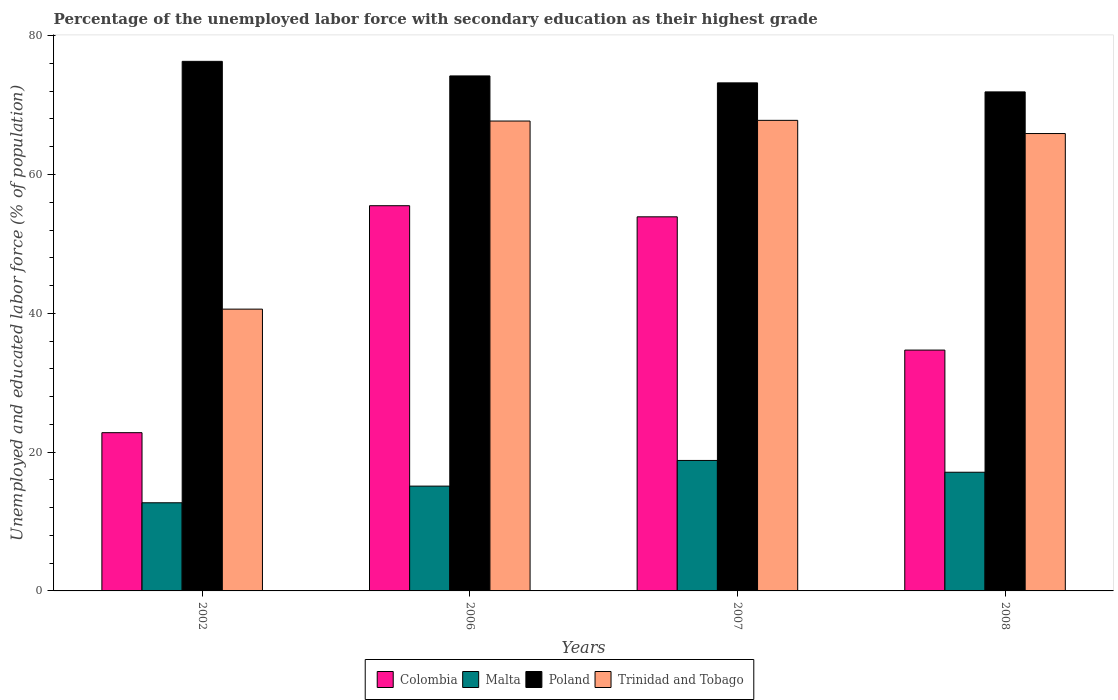How many different coloured bars are there?
Provide a short and direct response. 4. How many groups of bars are there?
Offer a terse response. 4. What is the percentage of the unemployed labor force with secondary education in Malta in 2008?
Your answer should be compact. 17.1. Across all years, what is the maximum percentage of the unemployed labor force with secondary education in Colombia?
Offer a very short reply. 55.5. Across all years, what is the minimum percentage of the unemployed labor force with secondary education in Malta?
Your answer should be very brief. 12.7. In which year was the percentage of the unemployed labor force with secondary education in Malta maximum?
Give a very brief answer. 2007. In which year was the percentage of the unemployed labor force with secondary education in Malta minimum?
Make the answer very short. 2002. What is the total percentage of the unemployed labor force with secondary education in Colombia in the graph?
Provide a short and direct response. 166.9. What is the difference between the percentage of the unemployed labor force with secondary education in Colombia in 2006 and that in 2008?
Your answer should be very brief. 20.8. What is the difference between the percentage of the unemployed labor force with secondary education in Trinidad and Tobago in 2008 and the percentage of the unemployed labor force with secondary education in Poland in 2006?
Your response must be concise. -8.3. What is the average percentage of the unemployed labor force with secondary education in Colombia per year?
Provide a short and direct response. 41.73. In the year 2002, what is the difference between the percentage of the unemployed labor force with secondary education in Malta and percentage of the unemployed labor force with secondary education in Poland?
Offer a terse response. -63.6. In how many years, is the percentage of the unemployed labor force with secondary education in Colombia greater than 8 %?
Provide a short and direct response. 4. What is the ratio of the percentage of the unemployed labor force with secondary education in Colombia in 2006 to that in 2008?
Offer a very short reply. 1.6. Is the percentage of the unemployed labor force with secondary education in Colombia in 2007 less than that in 2008?
Offer a very short reply. No. What is the difference between the highest and the second highest percentage of the unemployed labor force with secondary education in Malta?
Give a very brief answer. 1.7. What is the difference between the highest and the lowest percentage of the unemployed labor force with secondary education in Trinidad and Tobago?
Your response must be concise. 27.2. Is it the case that in every year, the sum of the percentage of the unemployed labor force with secondary education in Poland and percentage of the unemployed labor force with secondary education in Colombia is greater than the sum of percentage of the unemployed labor force with secondary education in Malta and percentage of the unemployed labor force with secondary education in Trinidad and Tobago?
Your answer should be very brief. No. What does the 2nd bar from the right in 2006 represents?
Your response must be concise. Poland. How many years are there in the graph?
Provide a succinct answer. 4. What is the difference between two consecutive major ticks on the Y-axis?
Ensure brevity in your answer.  20. Does the graph contain grids?
Provide a short and direct response. No. Where does the legend appear in the graph?
Your response must be concise. Bottom center. How are the legend labels stacked?
Provide a succinct answer. Horizontal. What is the title of the graph?
Your answer should be very brief. Percentage of the unemployed labor force with secondary education as their highest grade. Does "Cambodia" appear as one of the legend labels in the graph?
Your answer should be compact. No. What is the label or title of the Y-axis?
Keep it short and to the point. Unemployed and educated labor force (% of population). What is the Unemployed and educated labor force (% of population) in Colombia in 2002?
Offer a very short reply. 22.8. What is the Unemployed and educated labor force (% of population) of Malta in 2002?
Keep it short and to the point. 12.7. What is the Unemployed and educated labor force (% of population) in Poland in 2002?
Your response must be concise. 76.3. What is the Unemployed and educated labor force (% of population) of Trinidad and Tobago in 2002?
Your answer should be compact. 40.6. What is the Unemployed and educated labor force (% of population) in Colombia in 2006?
Provide a short and direct response. 55.5. What is the Unemployed and educated labor force (% of population) of Malta in 2006?
Your response must be concise. 15.1. What is the Unemployed and educated labor force (% of population) of Poland in 2006?
Offer a very short reply. 74.2. What is the Unemployed and educated labor force (% of population) of Trinidad and Tobago in 2006?
Keep it short and to the point. 67.7. What is the Unemployed and educated labor force (% of population) in Colombia in 2007?
Offer a very short reply. 53.9. What is the Unemployed and educated labor force (% of population) of Malta in 2007?
Offer a very short reply. 18.8. What is the Unemployed and educated labor force (% of population) of Poland in 2007?
Give a very brief answer. 73.2. What is the Unemployed and educated labor force (% of population) in Trinidad and Tobago in 2007?
Give a very brief answer. 67.8. What is the Unemployed and educated labor force (% of population) in Colombia in 2008?
Offer a very short reply. 34.7. What is the Unemployed and educated labor force (% of population) in Malta in 2008?
Offer a terse response. 17.1. What is the Unemployed and educated labor force (% of population) in Poland in 2008?
Offer a very short reply. 71.9. What is the Unemployed and educated labor force (% of population) of Trinidad and Tobago in 2008?
Your answer should be compact. 65.9. Across all years, what is the maximum Unemployed and educated labor force (% of population) of Colombia?
Offer a terse response. 55.5. Across all years, what is the maximum Unemployed and educated labor force (% of population) in Malta?
Your response must be concise. 18.8. Across all years, what is the maximum Unemployed and educated labor force (% of population) of Poland?
Ensure brevity in your answer.  76.3. Across all years, what is the maximum Unemployed and educated labor force (% of population) in Trinidad and Tobago?
Keep it short and to the point. 67.8. Across all years, what is the minimum Unemployed and educated labor force (% of population) of Colombia?
Your response must be concise. 22.8. Across all years, what is the minimum Unemployed and educated labor force (% of population) of Malta?
Make the answer very short. 12.7. Across all years, what is the minimum Unemployed and educated labor force (% of population) in Poland?
Your answer should be very brief. 71.9. Across all years, what is the minimum Unemployed and educated labor force (% of population) of Trinidad and Tobago?
Offer a terse response. 40.6. What is the total Unemployed and educated labor force (% of population) in Colombia in the graph?
Offer a very short reply. 166.9. What is the total Unemployed and educated labor force (% of population) in Malta in the graph?
Give a very brief answer. 63.7. What is the total Unemployed and educated labor force (% of population) in Poland in the graph?
Offer a very short reply. 295.6. What is the total Unemployed and educated labor force (% of population) of Trinidad and Tobago in the graph?
Your response must be concise. 242. What is the difference between the Unemployed and educated labor force (% of population) of Colombia in 2002 and that in 2006?
Provide a succinct answer. -32.7. What is the difference between the Unemployed and educated labor force (% of population) of Poland in 2002 and that in 2006?
Make the answer very short. 2.1. What is the difference between the Unemployed and educated labor force (% of population) in Trinidad and Tobago in 2002 and that in 2006?
Provide a short and direct response. -27.1. What is the difference between the Unemployed and educated labor force (% of population) in Colombia in 2002 and that in 2007?
Provide a short and direct response. -31.1. What is the difference between the Unemployed and educated labor force (% of population) in Malta in 2002 and that in 2007?
Make the answer very short. -6.1. What is the difference between the Unemployed and educated labor force (% of population) in Trinidad and Tobago in 2002 and that in 2007?
Your answer should be compact. -27.2. What is the difference between the Unemployed and educated labor force (% of population) of Colombia in 2002 and that in 2008?
Make the answer very short. -11.9. What is the difference between the Unemployed and educated labor force (% of population) of Malta in 2002 and that in 2008?
Make the answer very short. -4.4. What is the difference between the Unemployed and educated labor force (% of population) of Poland in 2002 and that in 2008?
Offer a very short reply. 4.4. What is the difference between the Unemployed and educated labor force (% of population) of Trinidad and Tobago in 2002 and that in 2008?
Keep it short and to the point. -25.3. What is the difference between the Unemployed and educated labor force (% of population) of Malta in 2006 and that in 2007?
Give a very brief answer. -3.7. What is the difference between the Unemployed and educated labor force (% of population) in Poland in 2006 and that in 2007?
Give a very brief answer. 1. What is the difference between the Unemployed and educated labor force (% of population) in Trinidad and Tobago in 2006 and that in 2007?
Offer a terse response. -0.1. What is the difference between the Unemployed and educated labor force (% of population) in Colombia in 2006 and that in 2008?
Ensure brevity in your answer.  20.8. What is the difference between the Unemployed and educated labor force (% of population) in Malta in 2006 and that in 2008?
Keep it short and to the point. -2. What is the difference between the Unemployed and educated labor force (% of population) of Poland in 2006 and that in 2008?
Offer a very short reply. 2.3. What is the difference between the Unemployed and educated labor force (% of population) in Colombia in 2007 and that in 2008?
Give a very brief answer. 19.2. What is the difference between the Unemployed and educated labor force (% of population) of Poland in 2007 and that in 2008?
Your answer should be very brief. 1.3. What is the difference between the Unemployed and educated labor force (% of population) in Trinidad and Tobago in 2007 and that in 2008?
Your response must be concise. 1.9. What is the difference between the Unemployed and educated labor force (% of population) in Colombia in 2002 and the Unemployed and educated labor force (% of population) in Malta in 2006?
Ensure brevity in your answer.  7.7. What is the difference between the Unemployed and educated labor force (% of population) of Colombia in 2002 and the Unemployed and educated labor force (% of population) of Poland in 2006?
Ensure brevity in your answer.  -51.4. What is the difference between the Unemployed and educated labor force (% of population) in Colombia in 2002 and the Unemployed and educated labor force (% of population) in Trinidad and Tobago in 2006?
Offer a very short reply. -44.9. What is the difference between the Unemployed and educated labor force (% of population) in Malta in 2002 and the Unemployed and educated labor force (% of population) in Poland in 2006?
Your answer should be very brief. -61.5. What is the difference between the Unemployed and educated labor force (% of population) of Malta in 2002 and the Unemployed and educated labor force (% of population) of Trinidad and Tobago in 2006?
Keep it short and to the point. -55. What is the difference between the Unemployed and educated labor force (% of population) of Poland in 2002 and the Unemployed and educated labor force (% of population) of Trinidad and Tobago in 2006?
Provide a short and direct response. 8.6. What is the difference between the Unemployed and educated labor force (% of population) in Colombia in 2002 and the Unemployed and educated labor force (% of population) in Malta in 2007?
Ensure brevity in your answer.  4. What is the difference between the Unemployed and educated labor force (% of population) of Colombia in 2002 and the Unemployed and educated labor force (% of population) of Poland in 2007?
Offer a very short reply. -50.4. What is the difference between the Unemployed and educated labor force (% of population) of Colombia in 2002 and the Unemployed and educated labor force (% of population) of Trinidad and Tobago in 2007?
Provide a short and direct response. -45. What is the difference between the Unemployed and educated labor force (% of population) of Malta in 2002 and the Unemployed and educated labor force (% of population) of Poland in 2007?
Offer a terse response. -60.5. What is the difference between the Unemployed and educated labor force (% of population) in Malta in 2002 and the Unemployed and educated labor force (% of population) in Trinidad and Tobago in 2007?
Make the answer very short. -55.1. What is the difference between the Unemployed and educated labor force (% of population) of Poland in 2002 and the Unemployed and educated labor force (% of population) of Trinidad and Tobago in 2007?
Offer a very short reply. 8.5. What is the difference between the Unemployed and educated labor force (% of population) in Colombia in 2002 and the Unemployed and educated labor force (% of population) in Poland in 2008?
Your answer should be very brief. -49.1. What is the difference between the Unemployed and educated labor force (% of population) in Colombia in 2002 and the Unemployed and educated labor force (% of population) in Trinidad and Tobago in 2008?
Give a very brief answer. -43.1. What is the difference between the Unemployed and educated labor force (% of population) of Malta in 2002 and the Unemployed and educated labor force (% of population) of Poland in 2008?
Keep it short and to the point. -59.2. What is the difference between the Unemployed and educated labor force (% of population) in Malta in 2002 and the Unemployed and educated labor force (% of population) in Trinidad and Tobago in 2008?
Your answer should be very brief. -53.2. What is the difference between the Unemployed and educated labor force (% of population) in Colombia in 2006 and the Unemployed and educated labor force (% of population) in Malta in 2007?
Your response must be concise. 36.7. What is the difference between the Unemployed and educated labor force (% of population) of Colombia in 2006 and the Unemployed and educated labor force (% of population) of Poland in 2007?
Your response must be concise. -17.7. What is the difference between the Unemployed and educated labor force (% of population) of Malta in 2006 and the Unemployed and educated labor force (% of population) of Poland in 2007?
Give a very brief answer. -58.1. What is the difference between the Unemployed and educated labor force (% of population) of Malta in 2006 and the Unemployed and educated labor force (% of population) of Trinidad and Tobago in 2007?
Ensure brevity in your answer.  -52.7. What is the difference between the Unemployed and educated labor force (% of population) in Poland in 2006 and the Unemployed and educated labor force (% of population) in Trinidad and Tobago in 2007?
Keep it short and to the point. 6.4. What is the difference between the Unemployed and educated labor force (% of population) in Colombia in 2006 and the Unemployed and educated labor force (% of population) in Malta in 2008?
Keep it short and to the point. 38.4. What is the difference between the Unemployed and educated labor force (% of population) of Colombia in 2006 and the Unemployed and educated labor force (% of population) of Poland in 2008?
Keep it short and to the point. -16.4. What is the difference between the Unemployed and educated labor force (% of population) in Malta in 2006 and the Unemployed and educated labor force (% of population) in Poland in 2008?
Your answer should be very brief. -56.8. What is the difference between the Unemployed and educated labor force (% of population) in Malta in 2006 and the Unemployed and educated labor force (% of population) in Trinidad and Tobago in 2008?
Offer a terse response. -50.8. What is the difference between the Unemployed and educated labor force (% of population) in Colombia in 2007 and the Unemployed and educated labor force (% of population) in Malta in 2008?
Your response must be concise. 36.8. What is the difference between the Unemployed and educated labor force (% of population) of Colombia in 2007 and the Unemployed and educated labor force (% of population) of Trinidad and Tobago in 2008?
Your answer should be compact. -12. What is the difference between the Unemployed and educated labor force (% of population) of Malta in 2007 and the Unemployed and educated labor force (% of population) of Poland in 2008?
Provide a succinct answer. -53.1. What is the difference between the Unemployed and educated labor force (% of population) in Malta in 2007 and the Unemployed and educated labor force (% of population) in Trinidad and Tobago in 2008?
Make the answer very short. -47.1. What is the average Unemployed and educated labor force (% of population) in Colombia per year?
Your answer should be very brief. 41.73. What is the average Unemployed and educated labor force (% of population) of Malta per year?
Your answer should be compact. 15.93. What is the average Unemployed and educated labor force (% of population) in Poland per year?
Your answer should be very brief. 73.9. What is the average Unemployed and educated labor force (% of population) of Trinidad and Tobago per year?
Offer a very short reply. 60.5. In the year 2002, what is the difference between the Unemployed and educated labor force (% of population) of Colombia and Unemployed and educated labor force (% of population) of Malta?
Provide a succinct answer. 10.1. In the year 2002, what is the difference between the Unemployed and educated labor force (% of population) in Colombia and Unemployed and educated labor force (% of population) in Poland?
Your answer should be very brief. -53.5. In the year 2002, what is the difference between the Unemployed and educated labor force (% of population) in Colombia and Unemployed and educated labor force (% of population) in Trinidad and Tobago?
Provide a short and direct response. -17.8. In the year 2002, what is the difference between the Unemployed and educated labor force (% of population) of Malta and Unemployed and educated labor force (% of population) of Poland?
Offer a terse response. -63.6. In the year 2002, what is the difference between the Unemployed and educated labor force (% of population) in Malta and Unemployed and educated labor force (% of population) in Trinidad and Tobago?
Your answer should be very brief. -27.9. In the year 2002, what is the difference between the Unemployed and educated labor force (% of population) in Poland and Unemployed and educated labor force (% of population) in Trinidad and Tobago?
Your answer should be compact. 35.7. In the year 2006, what is the difference between the Unemployed and educated labor force (% of population) of Colombia and Unemployed and educated labor force (% of population) of Malta?
Provide a short and direct response. 40.4. In the year 2006, what is the difference between the Unemployed and educated labor force (% of population) of Colombia and Unemployed and educated labor force (% of population) of Poland?
Provide a short and direct response. -18.7. In the year 2006, what is the difference between the Unemployed and educated labor force (% of population) of Colombia and Unemployed and educated labor force (% of population) of Trinidad and Tobago?
Your response must be concise. -12.2. In the year 2006, what is the difference between the Unemployed and educated labor force (% of population) in Malta and Unemployed and educated labor force (% of population) in Poland?
Give a very brief answer. -59.1. In the year 2006, what is the difference between the Unemployed and educated labor force (% of population) in Malta and Unemployed and educated labor force (% of population) in Trinidad and Tobago?
Give a very brief answer. -52.6. In the year 2006, what is the difference between the Unemployed and educated labor force (% of population) of Poland and Unemployed and educated labor force (% of population) of Trinidad and Tobago?
Your response must be concise. 6.5. In the year 2007, what is the difference between the Unemployed and educated labor force (% of population) in Colombia and Unemployed and educated labor force (% of population) in Malta?
Offer a very short reply. 35.1. In the year 2007, what is the difference between the Unemployed and educated labor force (% of population) of Colombia and Unemployed and educated labor force (% of population) of Poland?
Ensure brevity in your answer.  -19.3. In the year 2007, what is the difference between the Unemployed and educated labor force (% of population) in Malta and Unemployed and educated labor force (% of population) in Poland?
Make the answer very short. -54.4. In the year 2007, what is the difference between the Unemployed and educated labor force (% of population) of Malta and Unemployed and educated labor force (% of population) of Trinidad and Tobago?
Provide a succinct answer. -49. In the year 2007, what is the difference between the Unemployed and educated labor force (% of population) in Poland and Unemployed and educated labor force (% of population) in Trinidad and Tobago?
Keep it short and to the point. 5.4. In the year 2008, what is the difference between the Unemployed and educated labor force (% of population) in Colombia and Unemployed and educated labor force (% of population) in Poland?
Your answer should be compact. -37.2. In the year 2008, what is the difference between the Unemployed and educated labor force (% of population) of Colombia and Unemployed and educated labor force (% of population) of Trinidad and Tobago?
Keep it short and to the point. -31.2. In the year 2008, what is the difference between the Unemployed and educated labor force (% of population) of Malta and Unemployed and educated labor force (% of population) of Poland?
Make the answer very short. -54.8. In the year 2008, what is the difference between the Unemployed and educated labor force (% of population) of Malta and Unemployed and educated labor force (% of population) of Trinidad and Tobago?
Ensure brevity in your answer.  -48.8. In the year 2008, what is the difference between the Unemployed and educated labor force (% of population) of Poland and Unemployed and educated labor force (% of population) of Trinidad and Tobago?
Provide a succinct answer. 6. What is the ratio of the Unemployed and educated labor force (% of population) in Colombia in 2002 to that in 2006?
Provide a succinct answer. 0.41. What is the ratio of the Unemployed and educated labor force (% of population) in Malta in 2002 to that in 2006?
Give a very brief answer. 0.84. What is the ratio of the Unemployed and educated labor force (% of population) in Poland in 2002 to that in 2006?
Your answer should be very brief. 1.03. What is the ratio of the Unemployed and educated labor force (% of population) of Trinidad and Tobago in 2002 to that in 2006?
Offer a very short reply. 0.6. What is the ratio of the Unemployed and educated labor force (% of population) of Colombia in 2002 to that in 2007?
Keep it short and to the point. 0.42. What is the ratio of the Unemployed and educated labor force (% of population) in Malta in 2002 to that in 2007?
Give a very brief answer. 0.68. What is the ratio of the Unemployed and educated labor force (% of population) in Poland in 2002 to that in 2007?
Provide a short and direct response. 1.04. What is the ratio of the Unemployed and educated labor force (% of population) of Trinidad and Tobago in 2002 to that in 2007?
Make the answer very short. 0.6. What is the ratio of the Unemployed and educated labor force (% of population) of Colombia in 2002 to that in 2008?
Offer a terse response. 0.66. What is the ratio of the Unemployed and educated labor force (% of population) of Malta in 2002 to that in 2008?
Make the answer very short. 0.74. What is the ratio of the Unemployed and educated labor force (% of population) of Poland in 2002 to that in 2008?
Your answer should be very brief. 1.06. What is the ratio of the Unemployed and educated labor force (% of population) of Trinidad and Tobago in 2002 to that in 2008?
Provide a succinct answer. 0.62. What is the ratio of the Unemployed and educated labor force (% of population) in Colombia in 2006 to that in 2007?
Your response must be concise. 1.03. What is the ratio of the Unemployed and educated labor force (% of population) in Malta in 2006 to that in 2007?
Provide a short and direct response. 0.8. What is the ratio of the Unemployed and educated labor force (% of population) in Poland in 2006 to that in 2007?
Your answer should be very brief. 1.01. What is the ratio of the Unemployed and educated labor force (% of population) in Trinidad and Tobago in 2006 to that in 2007?
Your answer should be compact. 1. What is the ratio of the Unemployed and educated labor force (% of population) in Colombia in 2006 to that in 2008?
Give a very brief answer. 1.6. What is the ratio of the Unemployed and educated labor force (% of population) of Malta in 2006 to that in 2008?
Your response must be concise. 0.88. What is the ratio of the Unemployed and educated labor force (% of population) in Poland in 2006 to that in 2008?
Your answer should be very brief. 1.03. What is the ratio of the Unemployed and educated labor force (% of population) of Trinidad and Tobago in 2006 to that in 2008?
Your response must be concise. 1.03. What is the ratio of the Unemployed and educated labor force (% of population) of Colombia in 2007 to that in 2008?
Give a very brief answer. 1.55. What is the ratio of the Unemployed and educated labor force (% of population) of Malta in 2007 to that in 2008?
Keep it short and to the point. 1.1. What is the ratio of the Unemployed and educated labor force (% of population) in Poland in 2007 to that in 2008?
Make the answer very short. 1.02. What is the ratio of the Unemployed and educated labor force (% of population) of Trinidad and Tobago in 2007 to that in 2008?
Your response must be concise. 1.03. What is the difference between the highest and the second highest Unemployed and educated labor force (% of population) in Colombia?
Keep it short and to the point. 1.6. What is the difference between the highest and the second highest Unemployed and educated labor force (% of population) of Poland?
Provide a succinct answer. 2.1. What is the difference between the highest and the second highest Unemployed and educated labor force (% of population) in Trinidad and Tobago?
Offer a very short reply. 0.1. What is the difference between the highest and the lowest Unemployed and educated labor force (% of population) in Colombia?
Give a very brief answer. 32.7. What is the difference between the highest and the lowest Unemployed and educated labor force (% of population) of Poland?
Provide a short and direct response. 4.4. What is the difference between the highest and the lowest Unemployed and educated labor force (% of population) in Trinidad and Tobago?
Ensure brevity in your answer.  27.2. 